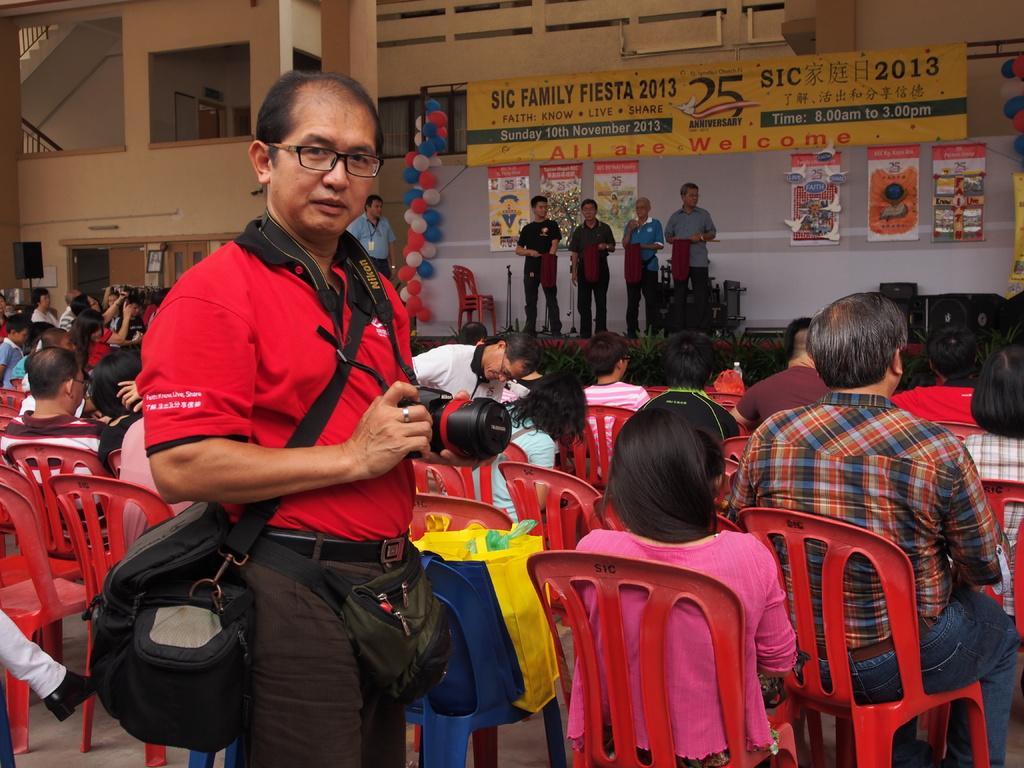Can you describe this image briefly? In this picture we can see people sitting on the chairs and there are few persons standing on the floor. There is a person holding a camera with his hands and he wore bags. In the background we can see a building, banners, balloons, and speakers. 